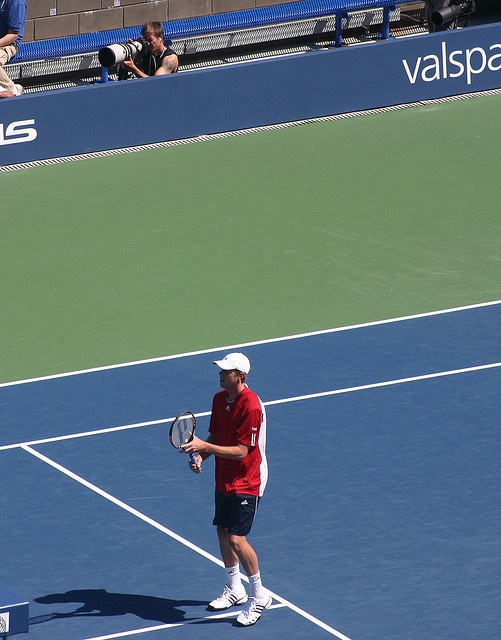Describe the objects in this image and their specific colors. I can see people in black, gray, white, and maroon tones, bench in black, navy, blue, and darkblue tones, people in black, gray, brown, and maroon tones, people in black, lightgray, navy, and blue tones, and tennis racket in black and gray tones in this image. 